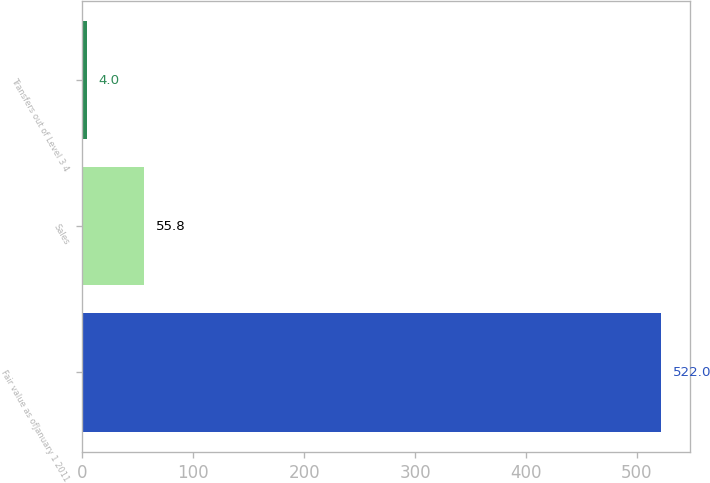<chart> <loc_0><loc_0><loc_500><loc_500><bar_chart><fcel>Fair value as ofJanuary 1 2011<fcel>Sales<fcel>Transfers out of Level 3 4<nl><fcel>522<fcel>55.8<fcel>4<nl></chart> 